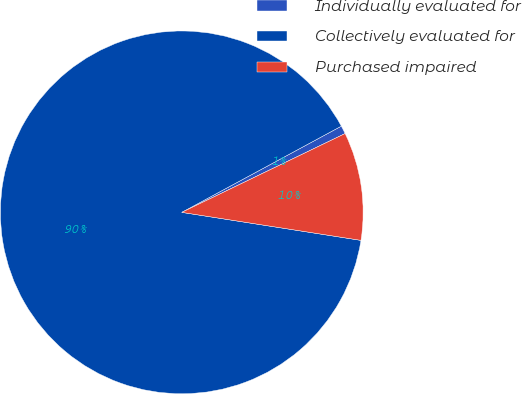<chart> <loc_0><loc_0><loc_500><loc_500><pie_chart><fcel>Individually evaluated for<fcel>Collectively evaluated for<fcel>Purchased impaired<nl><fcel>0.73%<fcel>89.64%<fcel>9.62%<nl></chart> 